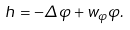Convert formula to latex. <formula><loc_0><loc_0><loc_500><loc_500>h = - \Delta \varphi + w _ { \varphi } \varphi .</formula> 